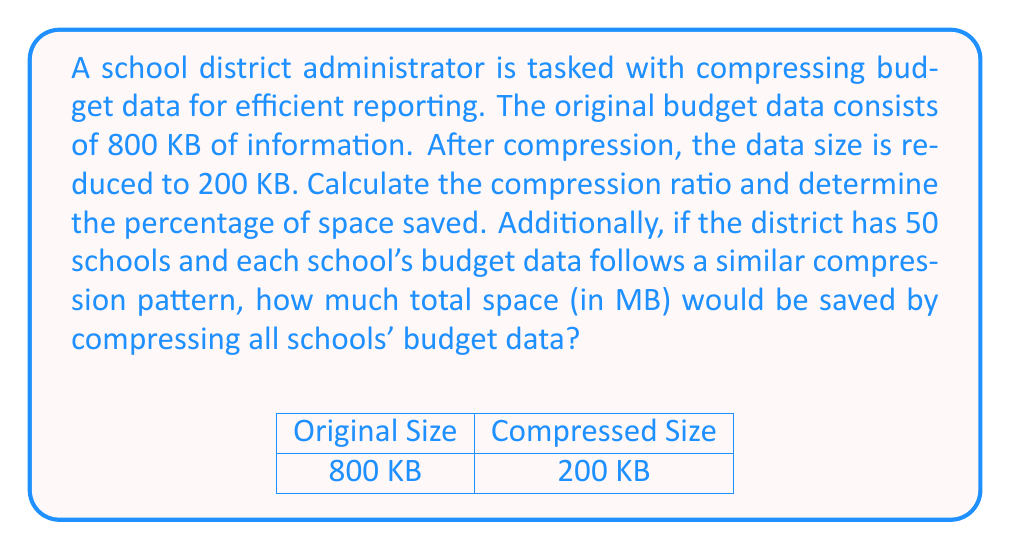Could you help me with this problem? Let's approach this step-by-step:

1. Calculate the compression ratio:
   Compression ratio = Original size / Compressed size
   $$ \text{Compression ratio} = \frac{800 \text{ KB}}{200 \text{ KB}} = 4:1 $$

2. Calculate the percentage of space saved:
   $$ \text{Space saved} = \frac{\text{Original size} - \text{Compressed size}}{\text{Original size}} \times 100\% $$
   $$ = \frac{800 \text{ KB} - 200 \text{ KB}}{800 \text{ KB}} \times 100\% = 75\% $$

3. Calculate total space saved for all 50 schools:
   - Space saved for one school = Original size - Compressed size
     $$ 800 \text{ KB} - 200 \text{ KB} = 600 \text{ KB} $$
   - Total space saved = Space saved per school × Number of schools
     $$ 600 \text{ KB} \times 50 = 30,000 \text{ KB} = 30 \text{ MB} $$
Answer: 4:1 ratio, 75% saved, 30 MB total saved 